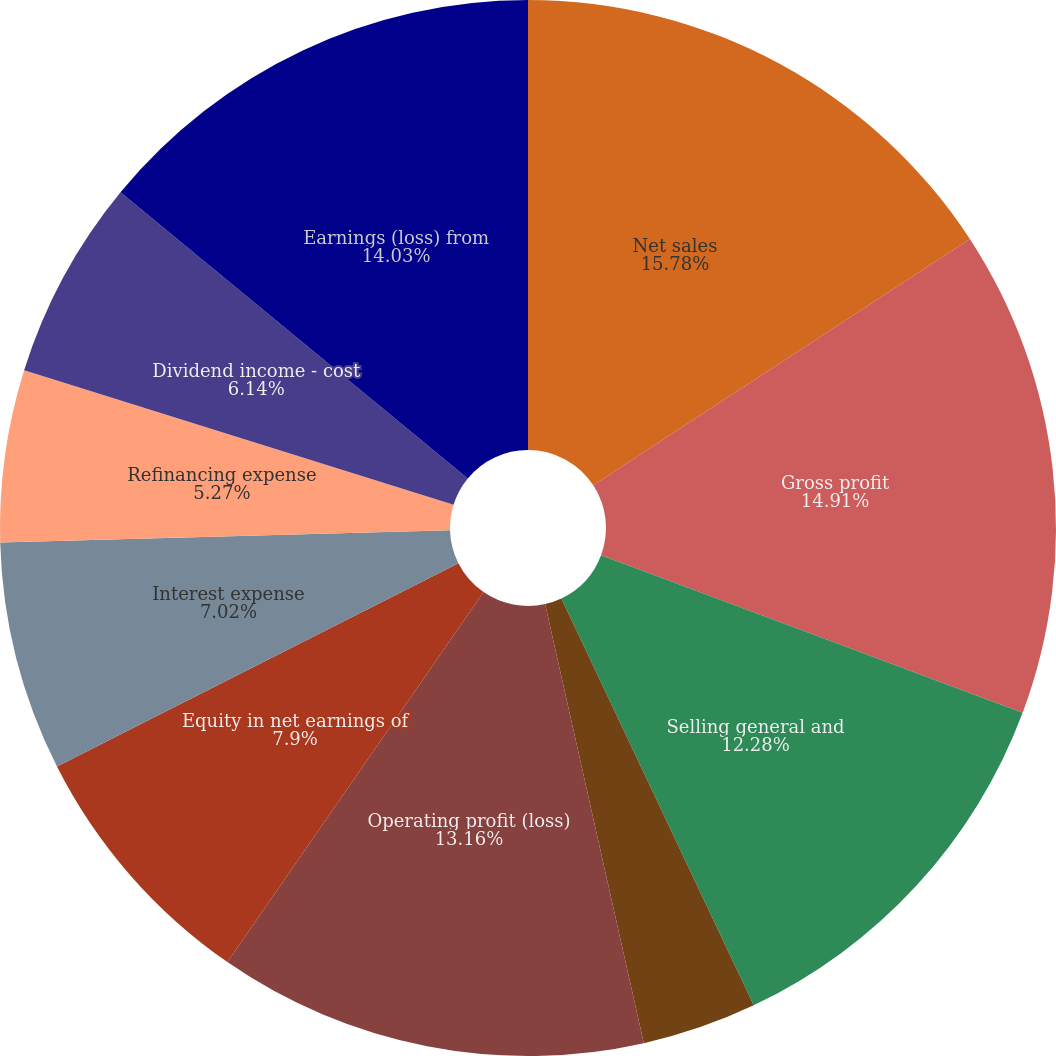Convert chart to OTSL. <chart><loc_0><loc_0><loc_500><loc_500><pie_chart><fcel>Net sales<fcel>Gross profit<fcel>Selling general and<fcel>Other (charges) gains net<fcel>Operating profit (loss)<fcel>Equity in net earnings of<fcel>Interest expense<fcel>Refinancing expense<fcel>Dividend income - cost<fcel>Earnings (loss) from<nl><fcel>15.78%<fcel>14.91%<fcel>12.28%<fcel>3.51%<fcel>13.16%<fcel>7.9%<fcel>7.02%<fcel>5.27%<fcel>6.14%<fcel>14.03%<nl></chart> 